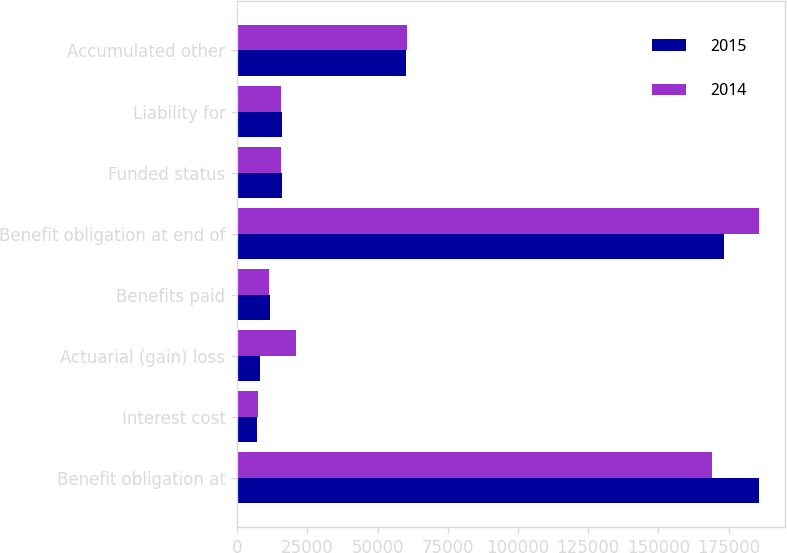Convert chart to OTSL. <chart><loc_0><loc_0><loc_500><loc_500><stacked_bar_chart><ecel><fcel>Benefit obligation at<fcel>Interest cost<fcel>Actuarial (gain) loss<fcel>Benefits paid<fcel>Benefit obligation at end of<fcel>Funded status<fcel>Liability for<fcel>Accumulated other<nl><fcel>2015<fcel>185944<fcel>7094<fcel>8085<fcel>11745<fcel>173208<fcel>15890<fcel>15890<fcel>60067<nl><fcel>2014<fcel>169092<fcel>7468<fcel>20859<fcel>11475<fcel>185944<fcel>15745<fcel>15745<fcel>60581<nl></chart> 